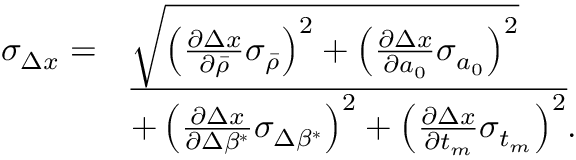Convert formula to latex. <formula><loc_0><loc_0><loc_500><loc_500>\begin{array} { r l } { \sigma _ { \Delta x } = } & { \sqrt { \left ( \frac { \partial \Delta x } { \partial \bar { \rho } } \sigma _ { \bar { \rho } } \right ) ^ { 2 } + \left ( \frac { \partial \Delta x } { \partial a _ { 0 } } \sigma _ { a _ { 0 } } \right ) ^ { 2 } } } \\ & { \overline { { + \left ( \frac { \partial \Delta x } { \partial \Delta \beta ^ { * } } \sigma _ { \Delta \beta ^ { * } } \right ) ^ { 2 } + \left ( \frac { \partial \Delta x } { \partial t _ { m } } \sigma _ { t _ { m } } \right ) ^ { 2 } } } . } \end{array}</formula> 